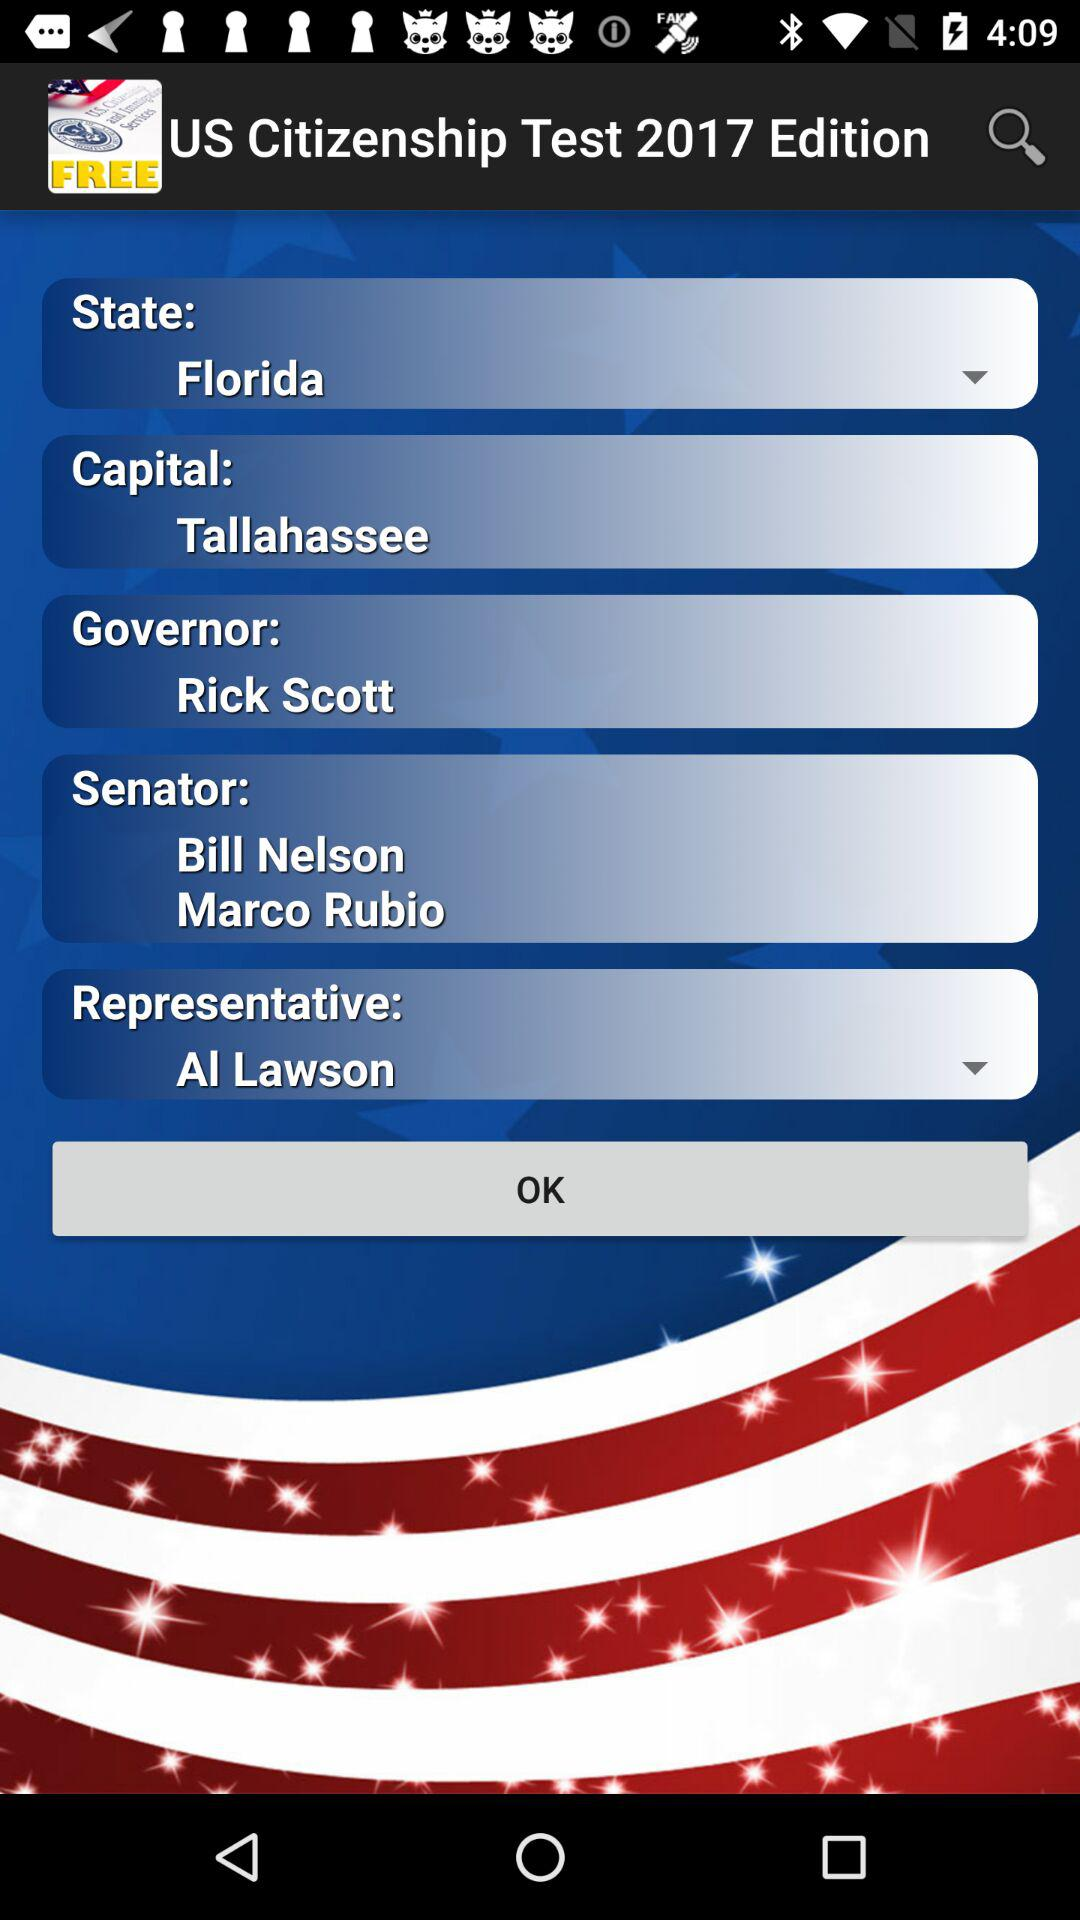Who is the senator? The senators are Bill Nelson and Marco Rubio. 